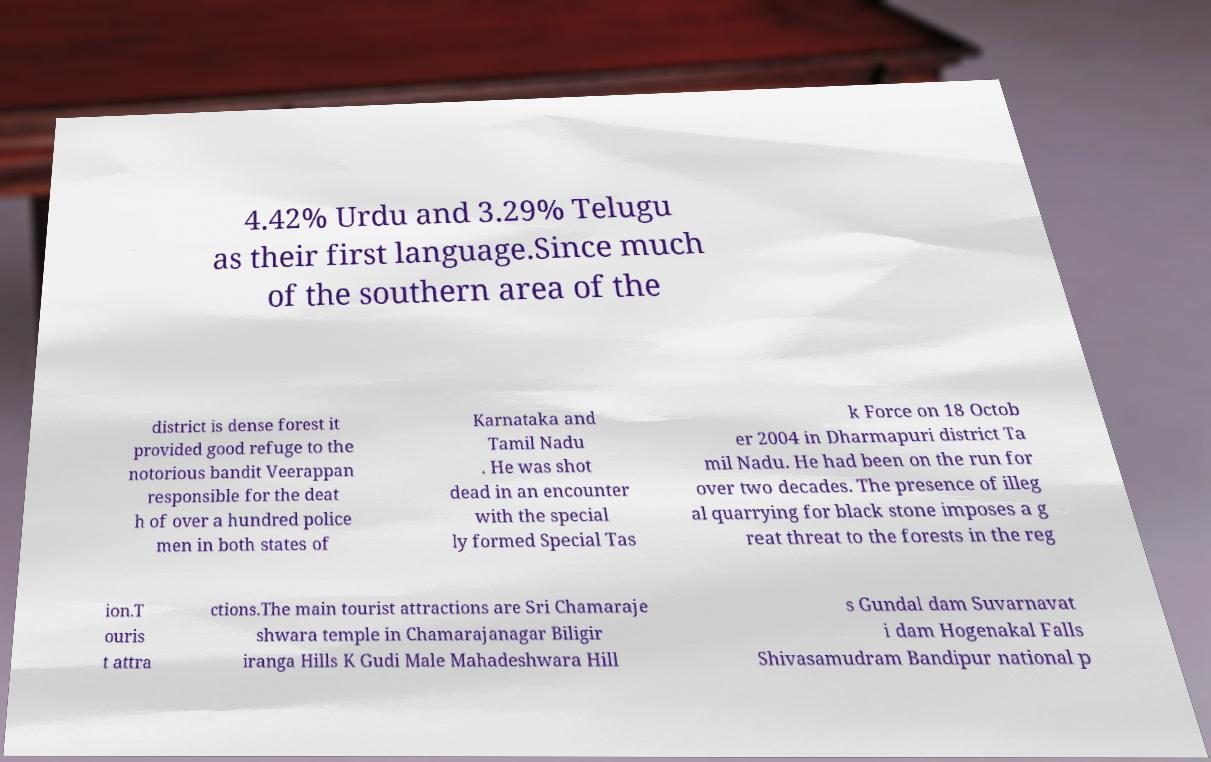Can you read and provide the text displayed in the image?This photo seems to have some interesting text. Can you extract and type it out for me? 4.42% Urdu and 3.29% Telugu as their first language.Since much of the southern area of the district is dense forest it provided good refuge to the notorious bandit Veerappan responsible for the deat h of over a hundred police men in both states of Karnataka and Tamil Nadu . He was shot dead in an encounter with the special ly formed Special Tas k Force on 18 Octob er 2004 in Dharmapuri district Ta mil Nadu. He had been on the run for over two decades. The presence of illeg al quarrying for black stone imposes a g reat threat to the forests in the reg ion.T ouris t attra ctions.The main tourist attractions are Sri Chamaraje shwara temple in Chamarajanagar Biligir iranga Hills K Gudi Male Mahadeshwara Hill s Gundal dam Suvarnavat i dam Hogenakal Falls Shivasamudram Bandipur national p 